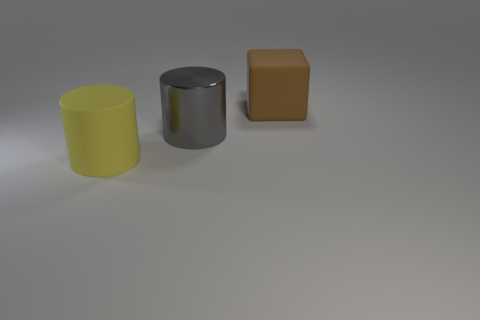Add 3 large blue spheres. How many objects exist? 6 Subtract all blocks. How many objects are left? 2 Subtract all big brown matte objects. Subtract all yellow cylinders. How many objects are left? 1 Add 1 gray metal things. How many gray metal things are left? 2 Add 3 matte things. How many matte things exist? 5 Subtract 0 purple cylinders. How many objects are left? 3 